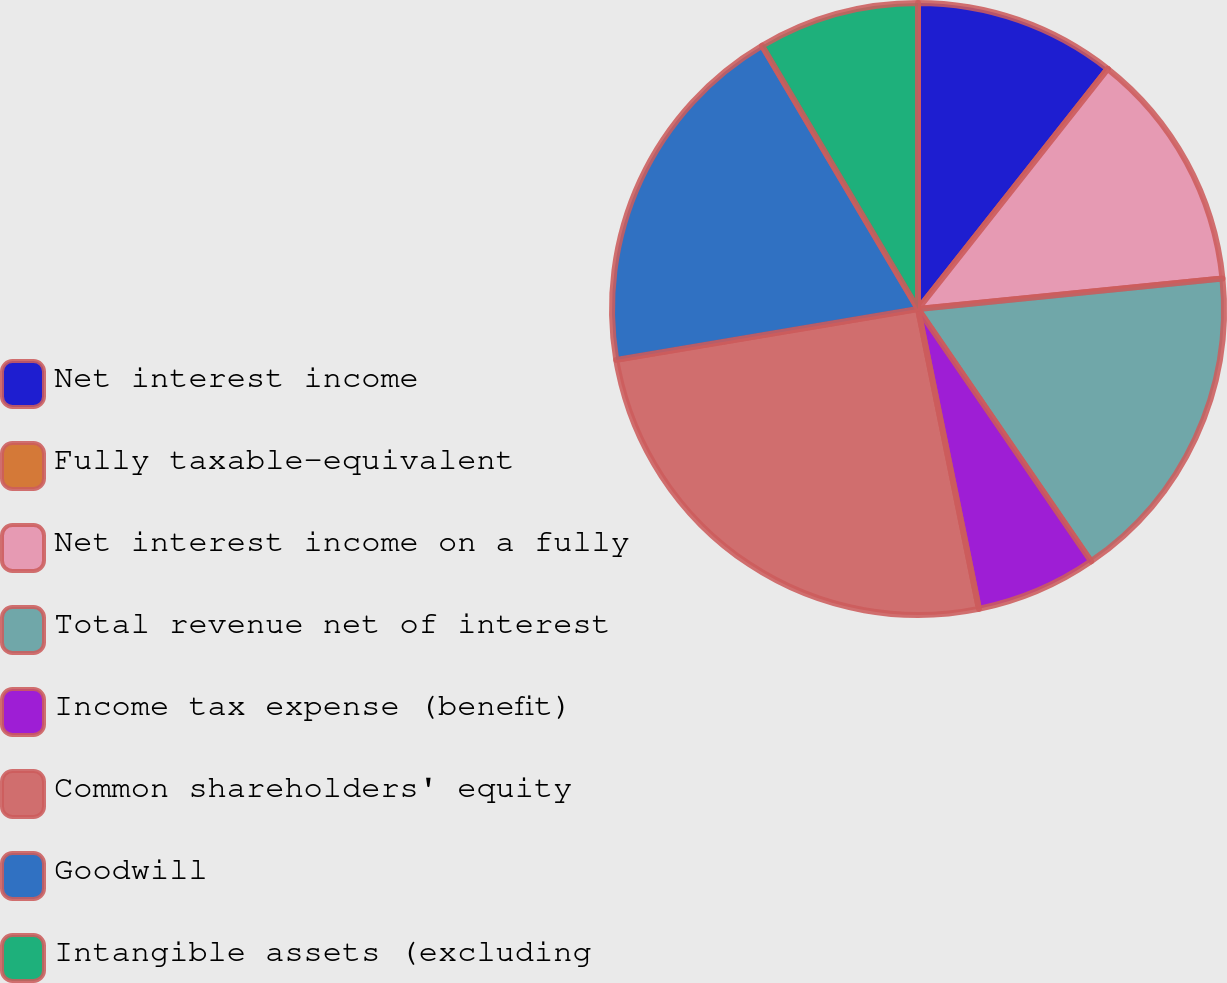Convert chart. <chart><loc_0><loc_0><loc_500><loc_500><pie_chart><fcel>Net interest income<fcel>Fully taxable-equivalent<fcel>Net interest income on a fully<fcel>Total revenue net of interest<fcel>Income tax expense (benefit)<fcel>Common shareholders' equity<fcel>Goodwill<fcel>Intangible assets (excluding<nl><fcel>10.64%<fcel>0.0%<fcel>12.77%<fcel>17.02%<fcel>6.38%<fcel>25.53%<fcel>19.15%<fcel>8.51%<nl></chart> 